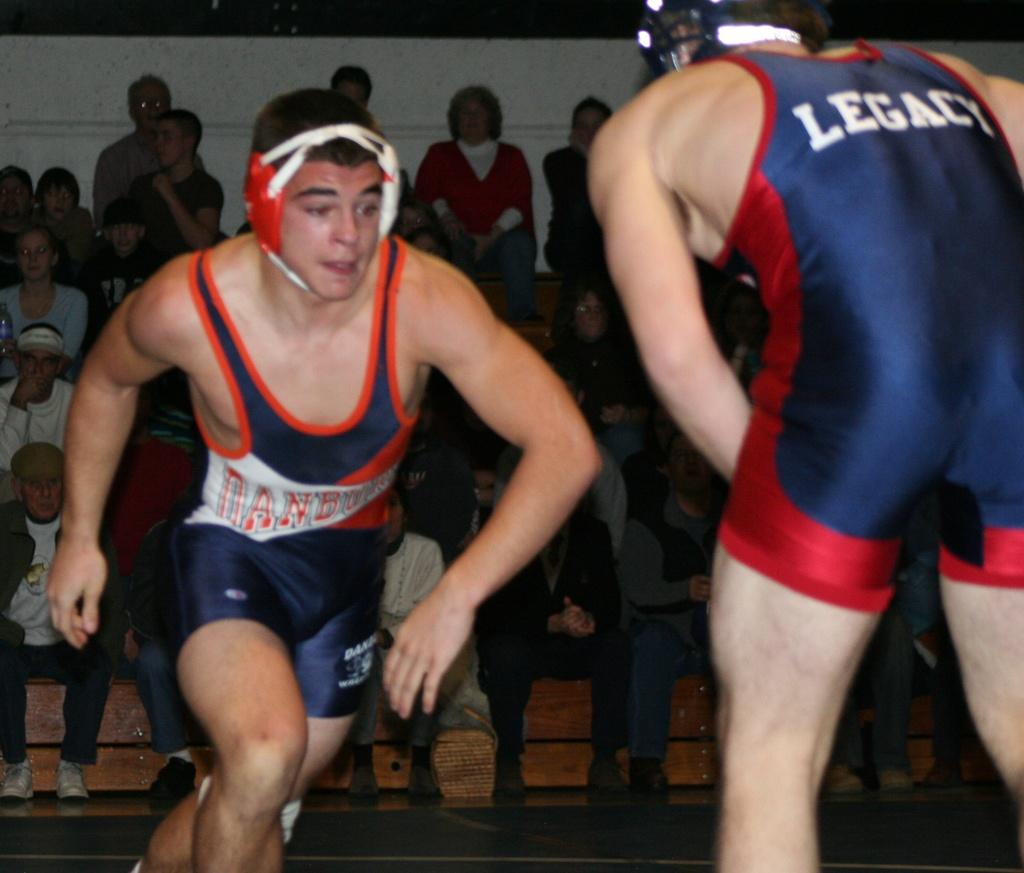<image>
Render a clear and concise summary of the photo. A wrestler has Legacy on the back of his uniform as he braces for a tackle. 